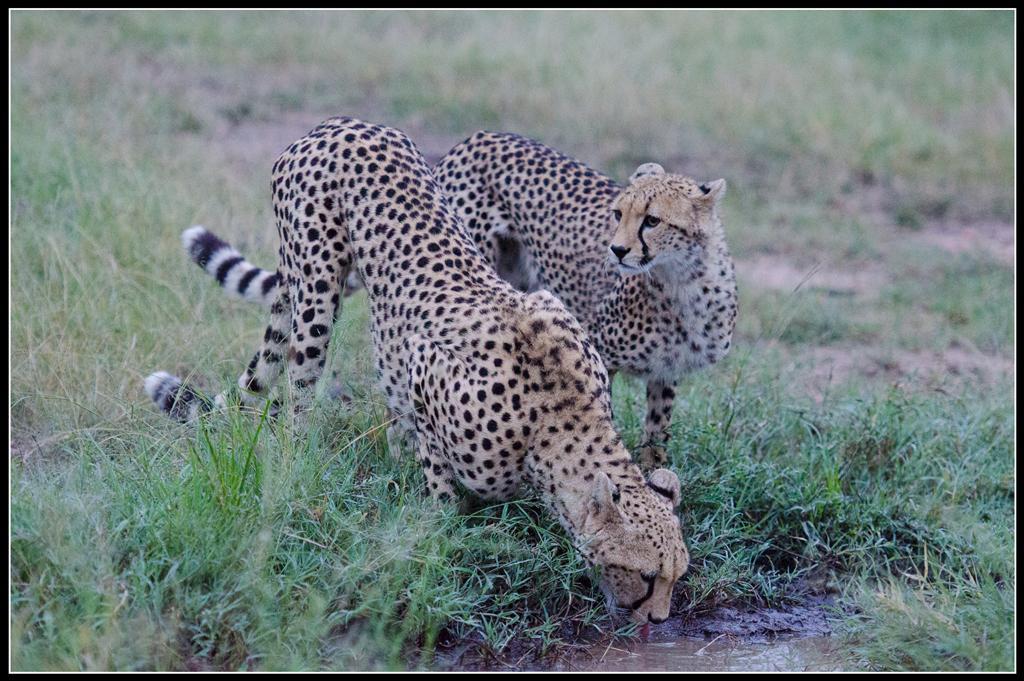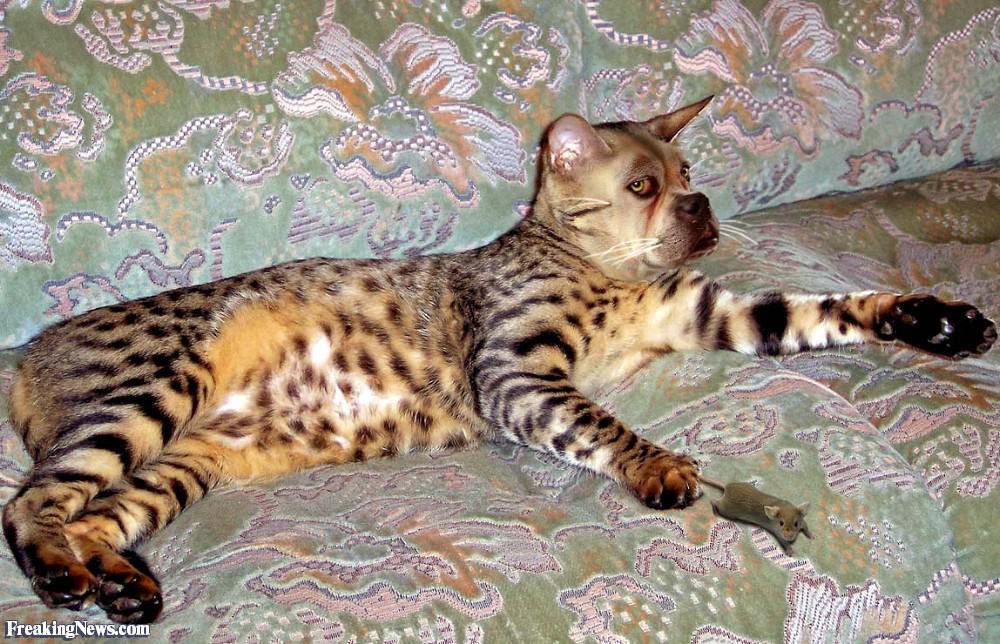The first image is the image on the left, the second image is the image on the right. Evaluate the accuracy of this statement regarding the images: "At least one image shows an animal that is not a cheetah.". Is it true? Answer yes or no. Yes. The first image is the image on the left, the second image is the image on the right. Analyze the images presented: Is the assertion "A cheetah's front paws are off the ground." valid? Answer yes or no. No. 